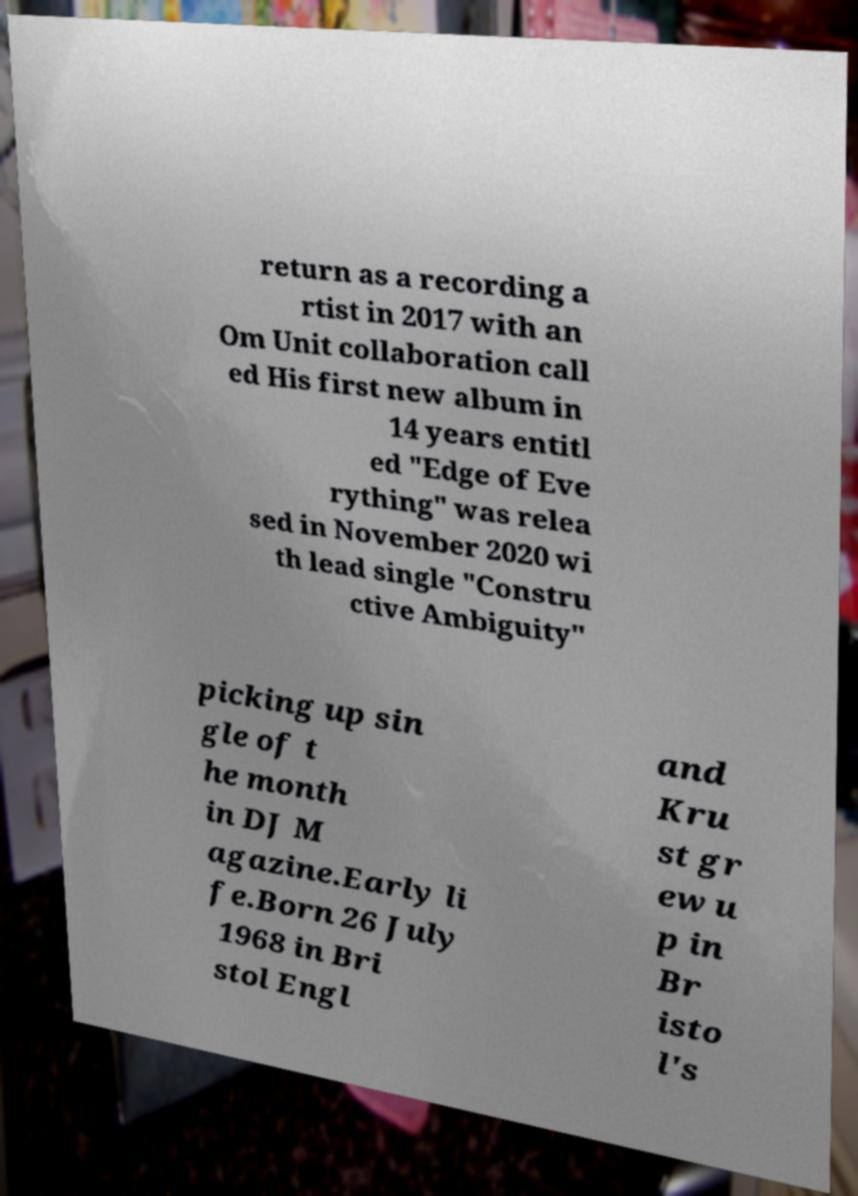Could you assist in decoding the text presented in this image and type it out clearly? return as a recording a rtist in 2017 with an Om Unit collaboration call ed His first new album in 14 years entitl ed "Edge of Eve rything" was relea sed in November 2020 wi th lead single "Constru ctive Ambiguity" picking up sin gle of t he month in DJ M agazine.Early li fe.Born 26 July 1968 in Bri stol Engl and Kru st gr ew u p in Br isto l's 